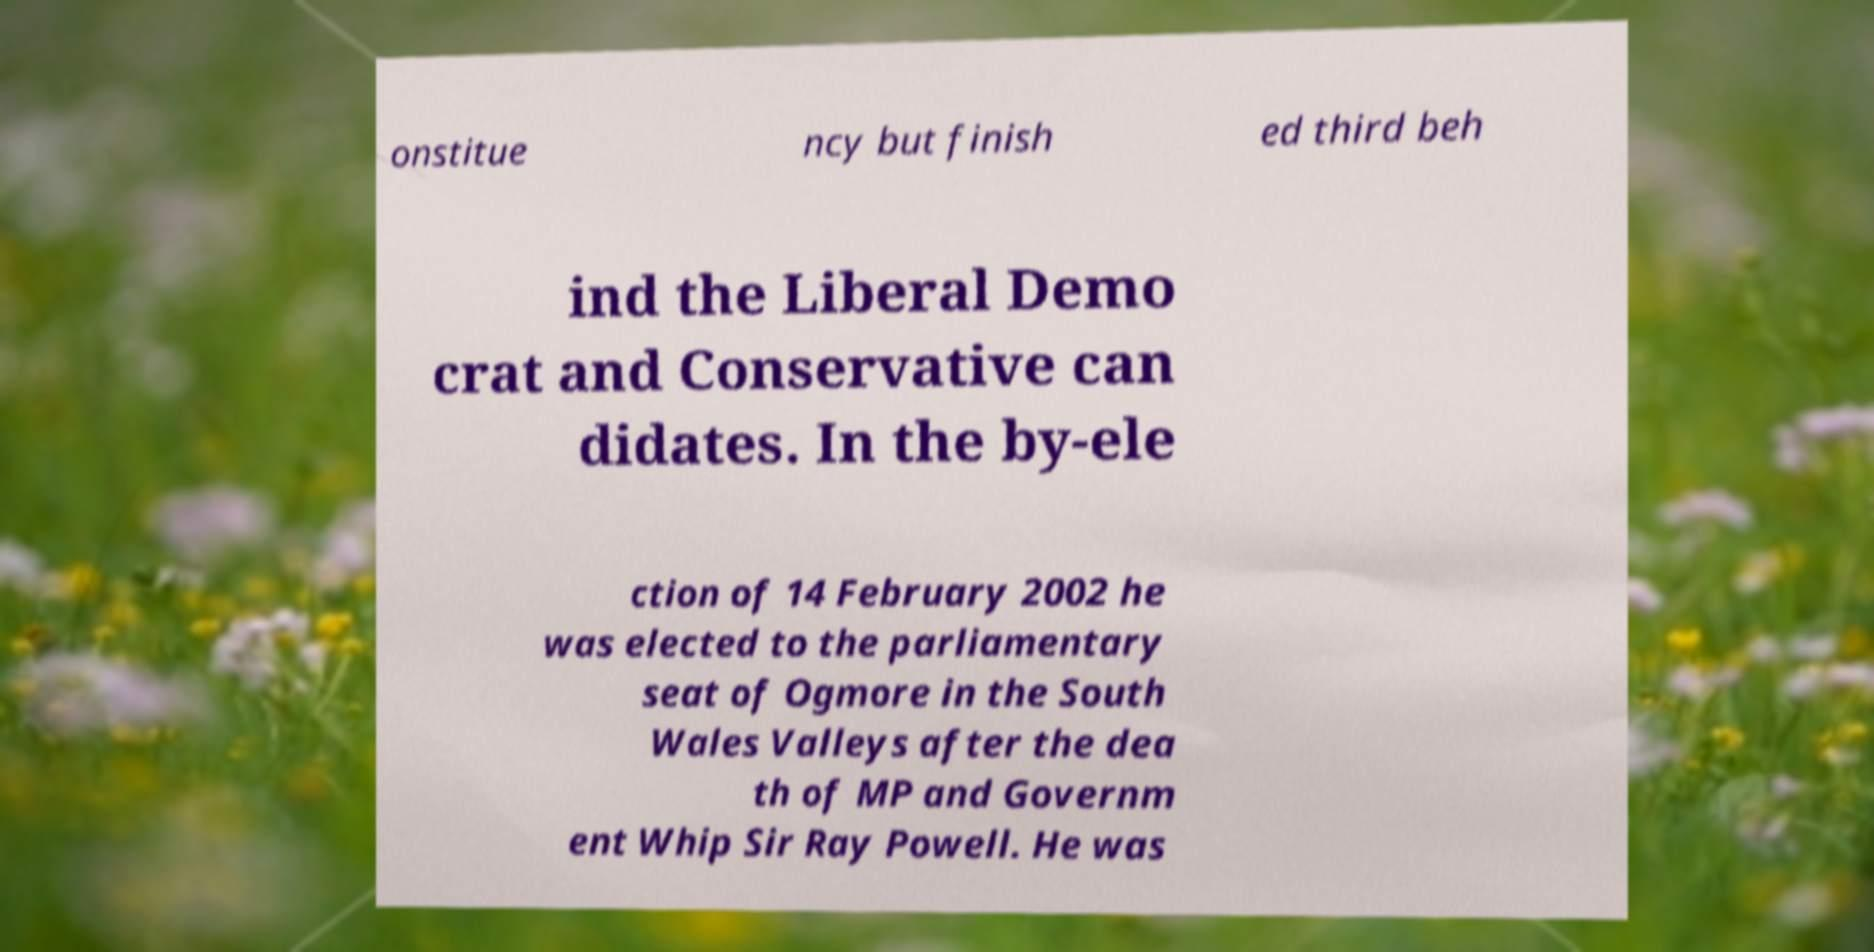What messages or text are displayed in this image? I need them in a readable, typed format. onstitue ncy but finish ed third beh ind the Liberal Demo crat and Conservative can didates. In the by-ele ction of 14 February 2002 he was elected to the parliamentary seat of Ogmore in the South Wales Valleys after the dea th of MP and Governm ent Whip Sir Ray Powell. He was 